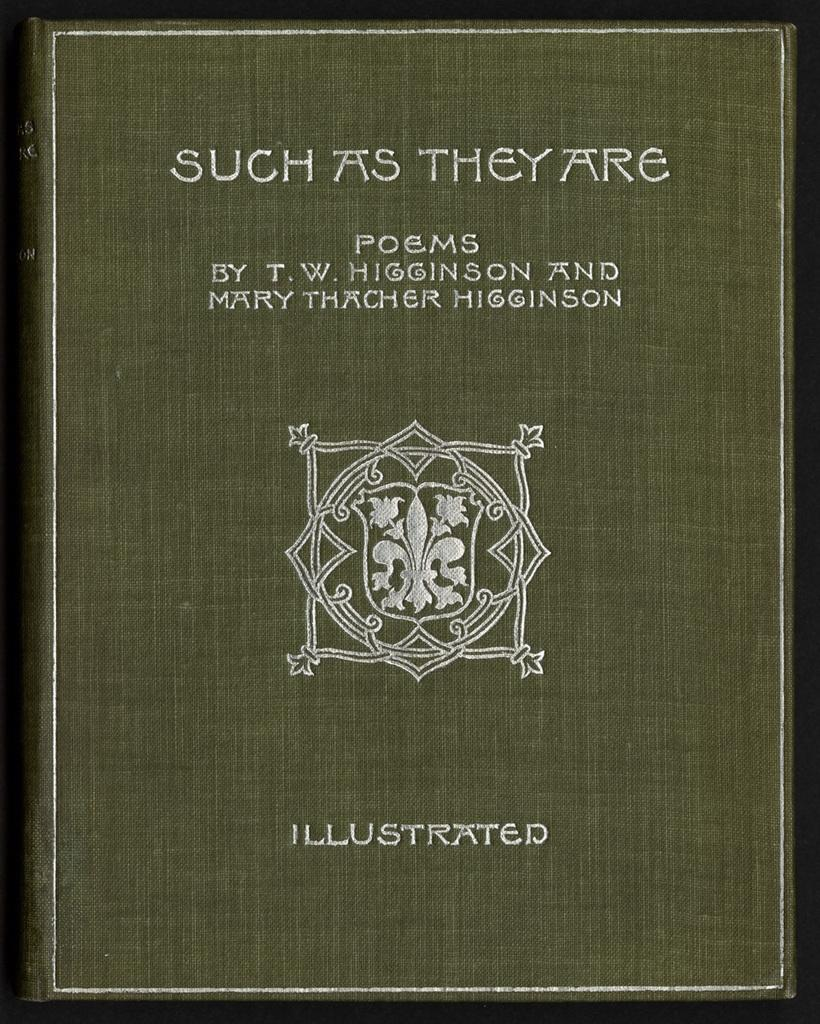<image>
Describe the image concisely. The collection of poems by T.W. Higginson and Mary Thatcher Higginson, "Such as They Are", is illustrated. 